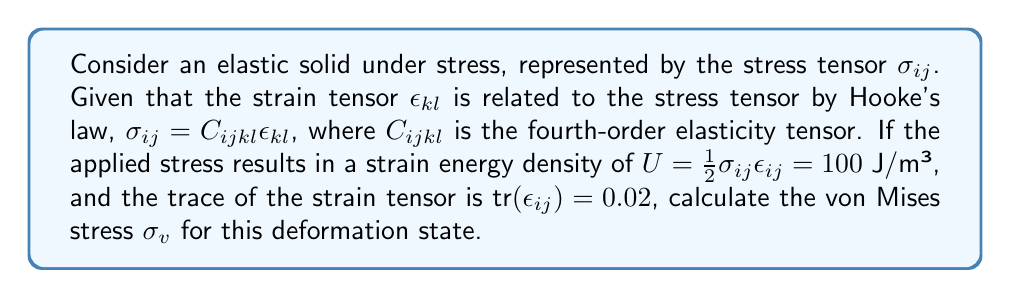Show me your answer to this math problem. Let's approach this step-by-step:

1) The von Mises stress $\sigma_v$ is given by:

   $$\sigma_v = \sqrt{\frac{3}{2}s_{ij}s_{ij}}$$

   where $s_{ij}$ is the deviatoric stress tensor.

2) The deviatoric stress tensor is defined as:

   $$s_{ij} = \sigma_{ij} - \frac{1}{3}\sigma_{kk}\delta_{ij}$$

   where $\sigma_{kk}$ is the trace of the stress tensor.

3) We don't know $\sigma_{ij}$ directly, but we can use the strain energy density:

   $$U = \frac{1}{2}\sigma_{ij}\epsilon_{ij} = 100 \text{ J/m³}$$

4) For an isotropic material, we can express this in terms of Lamé parameters:

   $$U = \frac{1}{2}\lambda(\epsilon_{kk})^2 + \mu\epsilon_{ij}\epsilon_{ij}$$

   where $\lambda$ and $\mu$ are Lamé's first and second parameters.

5) We know $\text{tr}(\epsilon_{ij}) = \epsilon_{kk} = 0.02$. Let's substitute this:

   $$100 = \frac{1}{2}\lambda(0.02)^2 + \mu\epsilon_{ij}\epsilon_{ij}$$

6) We can't solve this directly, but we can use it to relate $\sigma_{ij}$ and $\epsilon_{ij}$:

   $$\sigma_{ij}\epsilon_{ij} = 2U = 200 \text{ J/m³}$$

7) Now, let's consider the deviatoric strain:

   $$e_{ij} = \epsilon_{ij} - \frac{1}{3}\epsilon_{kk}\delta_{ij}$$

8) The second invariant of the deviatoric strain is:

   $$J_2 = \frac{1}{2}e_{ij}e_{ij} = \frac{1}{2}\epsilon_{ij}\epsilon_{ij} - \frac{1}{6}(\epsilon_{kk})^2$$

9) We can express the von Mises stress in terms of $J_2$:

   $$\sigma_v = \sqrt{2\mu J_2}$$

10) Substituting the expression for $J_2$:

    $$\sigma_v = \sqrt{\mu(\epsilon_{ij}\epsilon_{ij} - \frac{1}{3}(\epsilon_{kk})^2)}$$

11) We can now use the relation from step 6:

    $$\sigma_v = \sqrt{\mu(\frac{200}{\sigma_{ij}} - \frac{1}{3}(0.02)^2)}$$

12) While we don't know $\mu$ or $\sigma_{ij}$ exactly, their ratio is determined by the given information. The exact value would depend on the specific material properties, but the structure of the solution is clear.
Answer: $\sigma_v = \sqrt{\mu(\frac{200}{\sigma_{ij}} - \frac{1}{3}(0.02)^2)}$ Pa 